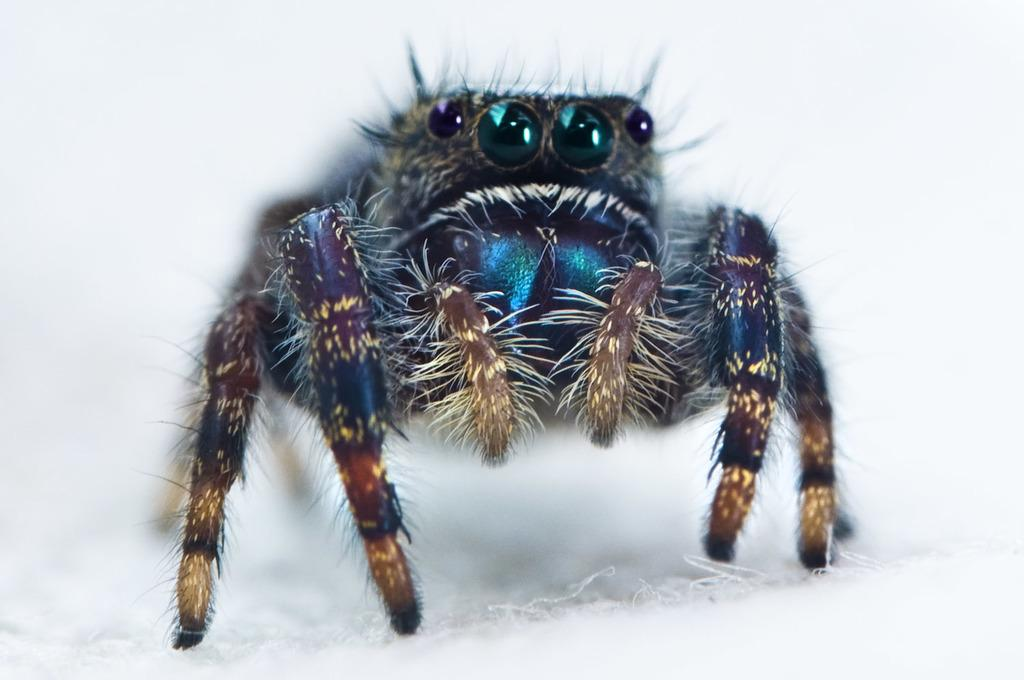What type of creature is present in the image? There is an insect in the image. Can you describe the appearance of the insect? The insect is colorful. What is the background or surface on which the insect is located? The insect is on a white surface. What type of chalk is being used to draw on the white surface in the image? There is no chalk present in the image; it features an insect on a white surface. How many berries are visible in the image? There are no berries present in the image. 